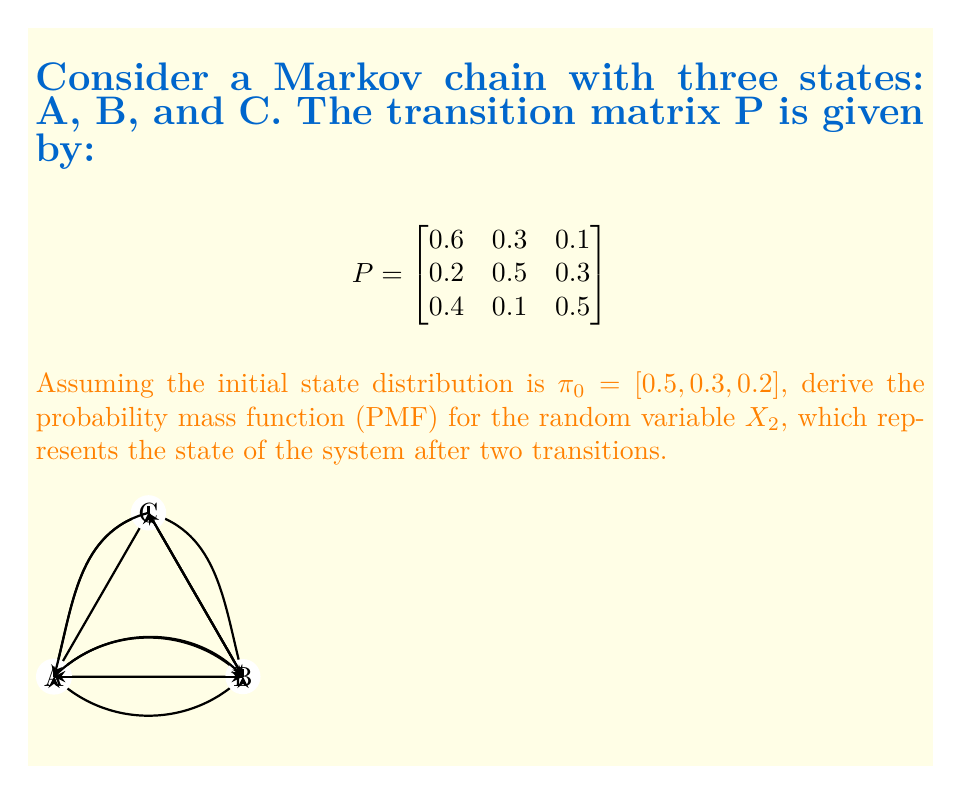Solve this math problem. To derive the PMF for $X_2$, we need to calculate the probability of being in each state after two transitions. We can do this using the Chapman-Kolmogorov equations.

Step 1: Calculate $P^2$ (the transition matrix after two steps)
$$P^2 = P \times P = \begin{bmatrix}
0.6 & 0.3 & 0.1 \\
0.2 & 0.5 & 0.3 \\
0.4 & 0.1 & 0.5
\end{bmatrix} \times \begin{bmatrix}
0.6 & 0.3 & 0.1 \\
0.2 & 0.5 & 0.3 \\
0.4 & 0.1 & 0.5
\end{bmatrix}$$

$$P^2 = \begin{bmatrix}
0.44 & 0.33 & 0.23 \\
0.34 & 0.35 & 0.31 \\
0.48 & 0.23 & 0.29
\end{bmatrix}$$

Step 2: Calculate the probability distribution after two transitions
$$\pi_2 = \pi_0 \times P^2 = [0.5, 0.3, 0.2] \times \begin{bmatrix}
0.44 & 0.33 & 0.23 \\
0.34 & 0.35 & 0.31 \\
0.48 & 0.23 & 0.29
\end{bmatrix}$$

$$\pi_2 = [0.418, 0.318, 0.264]$$

Step 3: Define the PMF for $X_2$
The PMF for $X_2$ is given by:

$$P(X_2 = x) = \begin{cases}
0.418 & \text{if } x = A \\
0.318 & \text{if } x = B \\
0.264 & \text{if } x = C \\
0 & \text{otherwise}
\end{cases}$$

This PMF satisfies the properties of a probability mass function:
1. $P(X_2 = x) \geq 0$ for all $x$
2. $\sum_x P(X_2 = x) = 0.418 + 0.318 + 0.264 = 1$
Answer: $P(X_2 = x) = \begin{cases}
0.418 & \text{if } x = A \\
0.318 & \text{if } x = B \\
0.264 & \text{if } x = C \\
0 & \text{otherwise}
\end{cases}$ 